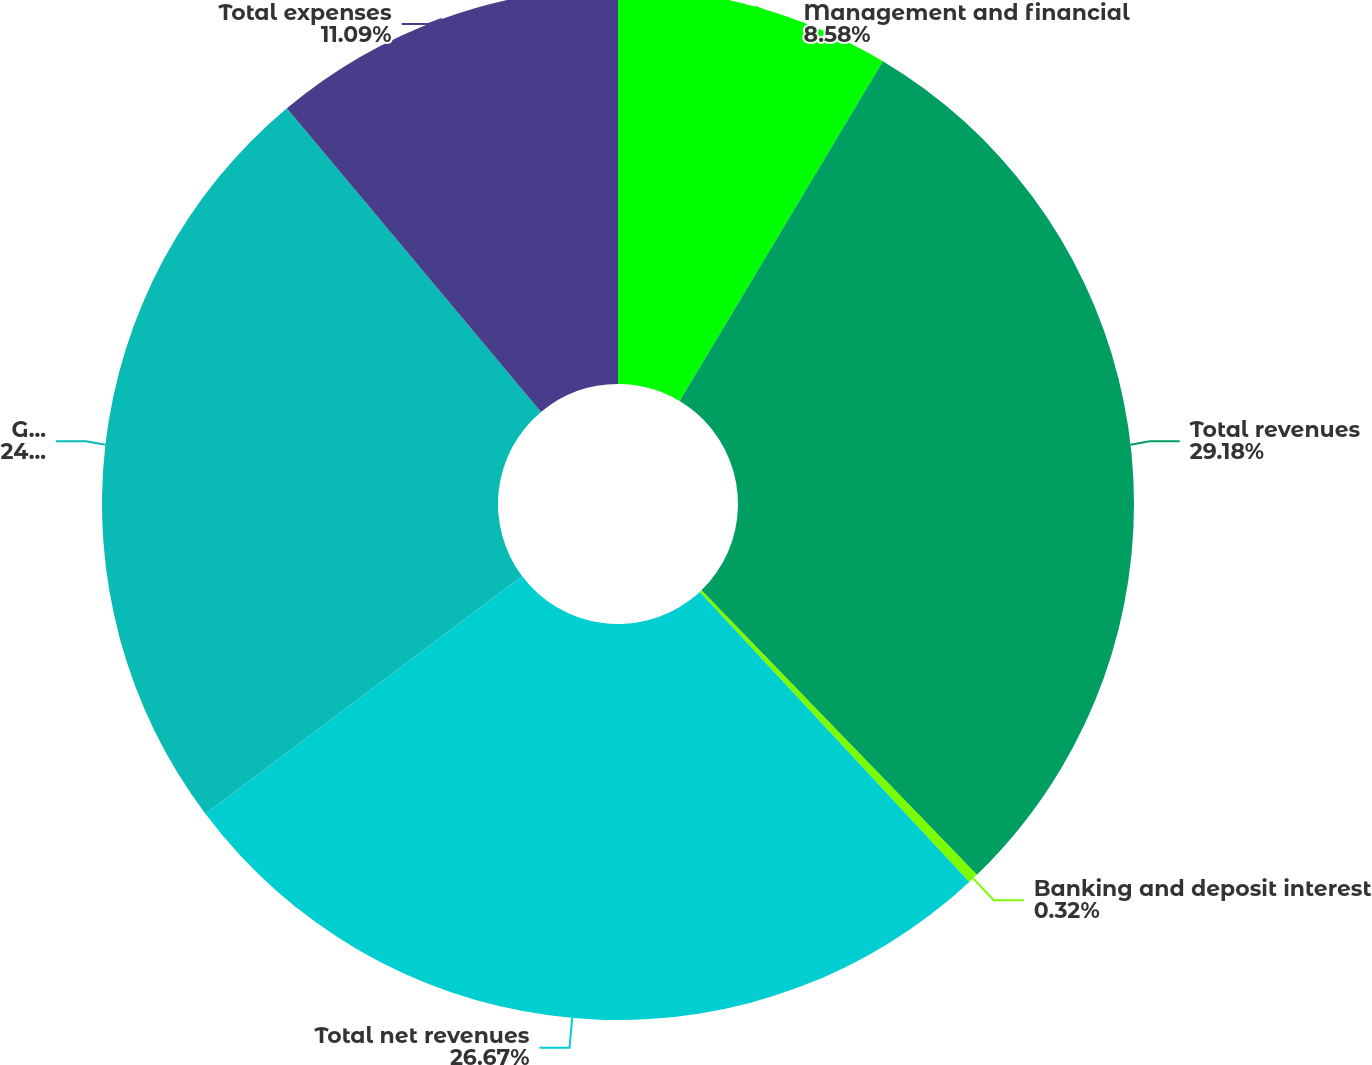Convert chart to OTSL. <chart><loc_0><loc_0><loc_500><loc_500><pie_chart><fcel>Management and financial<fcel>Total revenues<fcel>Banking and deposit interest<fcel>Total net revenues<fcel>General and administrative<fcel>Total expenses<nl><fcel>8.58%<fcel>29.18%<fcel>0.32%<fcel>26.67%<fcel>24.16%<fcel>11.09%<nl></chart> 